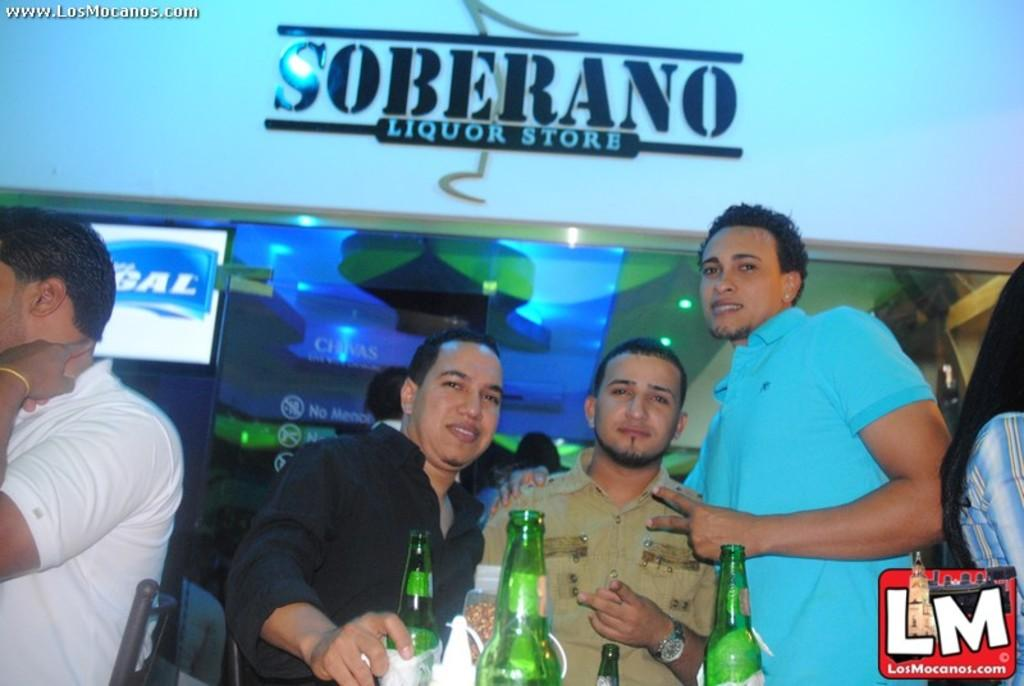Provide a one-sentence caption for the provided image. A group of men are partying under a sign that says Soberano Liquor Store. 